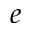Convert formula to latex. <formula><loc_0><loc_0><loc_500><loc_500>e</formula> 